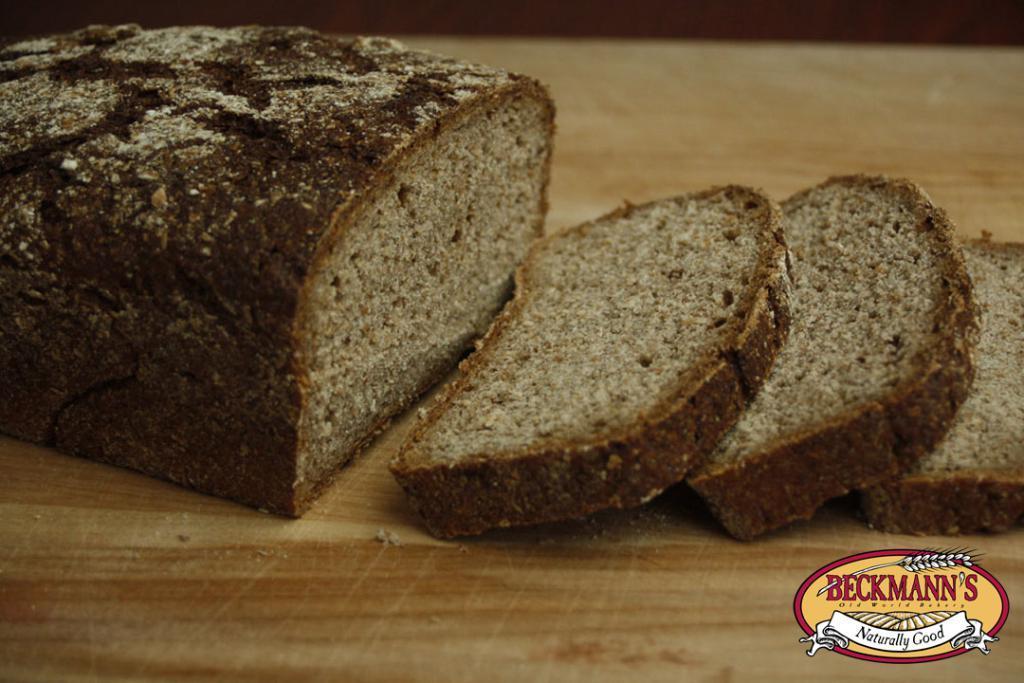Describe this image in one or two sentences. In this picture we can see chocolate bread and their pieces on the table. On the bottom right corner there is a watermark. 